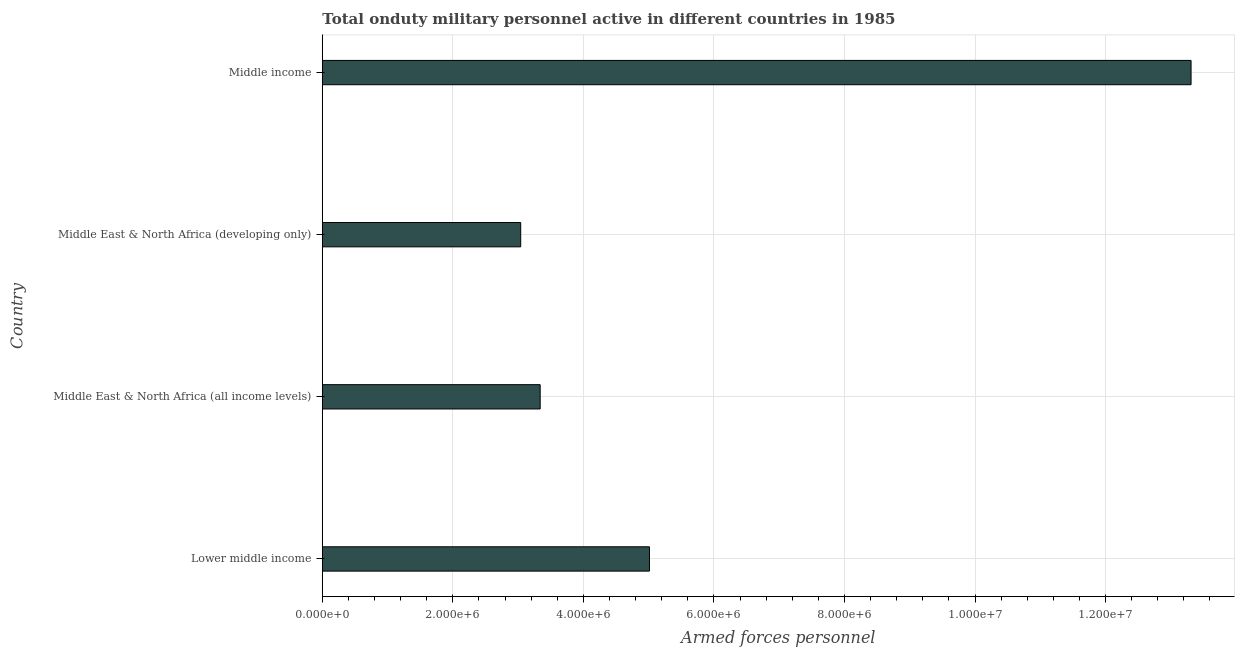What is the title of the graph?
Your answer should be compact. Total onduty military personnel active in different countries in 1985. What is the label or title of the X-axis?
Provide a short and direct response. Armed forces personnel. What is the label or title of the Y-axis?
Ensure brevity in your answer.  Country. What is the number of armed forces personnel in Middle East & North Africa (all income levels)?
Make the answer very short. 3.34e+06. Across all countries, what is the maximum number of armed forces personnel?
Offer a terse response. 1.33e+07. Across all countries, what is the minimum number of armed forces personnel?
Ensure brevity in your answer.  3.04e+06. In which country was the number of armed forces personnel maximum?
Offer a terse response. Middle income. In which country was the number of armed forces personnel minimum?
Your answer should be very brief. Middle East & North Africa (developing only). What is the sum of the number of armed forces personnel?
Your answer should be compact. 2.47e+07. What is the difference between the number of armed forces personnel in Lower middle income and Middle East & North Africa (developing only)?
Provide a succinct answer. 1.97e+06. What is the average number of armed forces personnel per country?
Provide a succinct answer. 6.17e+06. What is the median number of armed forces personnel?
Keep it short and to the point. 4.17e+06. What is the ratio of the number of armed forces personnel in Middle East & North Africa (all income levels) to that in Middle income?
Offer a terse response. 0.25. What is the difference between the highest and the second highest number of armed forces personnel?
Your answer should be very brief. 8.30e+06. Is the sum of the number of armed forces personnel in Lower middle income and Middle East & North Africa (developing only) greater than the maximum number of armed forces personnel across all countries?
Your response must be concise. No. What is the difference between the highest and the lowest number of armed forces personnel?
Keep it short and to the point. 1.03e+07. In how many countries, is the number of armed forces personnel greater than the average number of armed forces personnel taken over all countries?
Make the answer very short. 1. How many countries are there in the graph?
Ensure brevity in your answer.  4. What is the difference between two consecutive major ticks on the X-axis?
Provide a succinct answer. 2.00e+06. What is the Armed forces personnel in Lower middle income?
Provide a short and direct response. 5.01e+06. What is the Armed forces personnel of Middle East & North Africa (all income levels)?
Offer a very short reply. 3.34e+06. What is the Armed forces personnel of Middle East & North Africa (developing only)?
Ensure brevity in your answer.  3.04e+06. What is the Armed forces personnel in Middle income?
Provide a short and direct response. 1.33e+07. What is the difference between the Armed forces personnel in Lower middle income and Middle East & North Africa (all income levels)?
Your response must be concise. 1.67e+06. What is the difference between the Armed forces personnel in Lower middle income and Middle East & North Africa (developing only)?
Give a very brief answer. 1.97e+06. What is the difference between the Armed forces personnel in Lower middle income and Middle income?
Ensure brevity in your answer.  -8.30e+06. What is the difference between the Armed forces personnel in Middle East & North Africa (all income levels) and Middle East & North Africa (developing only)?
Your answer should be compact. 2.98e+05. What is the difference between the Armed forces personnel in Middle East & North Africa (all income levels) and Middle income?
Your answer should be very brief. -9.97e+06. What is the difference between the Armed forces personnel in Middle East & North Africa (developing only) and Middle income?
Provide a short and direct response. -1.03e+07. What is the ratio of the Armed forces personnel in Lower middle income to that in Middle East & North Africa (all income levels)?
Provide a succinct answer. 1.5. What is the ratio of the Armed forces personnel in Lower middle income to that in Middle East & North Africa (developing only)?
Provide a succinct answer. 1.65. What is the ratio of the Armed forces personnel in Lower middle income to that in Middle income?
Ensure brevity in your answer.  0.38. What is the ratio of the Armed forces personnel in Middle East & North Africa (all income levels) to that in Middle East & North Africa (developing only)?
Make the answer very short. 1.1. What is the ratio of the Armed forces personnel in Middle East & North Africa (all income levels) to that in Middle income?
Your answer should be very brief. 0.25. What is the ratio of the Armed forces personnel in Middle East & North Africa (developing only) to that in Middle income?
Ensure brevity in your answer.  0.23. 